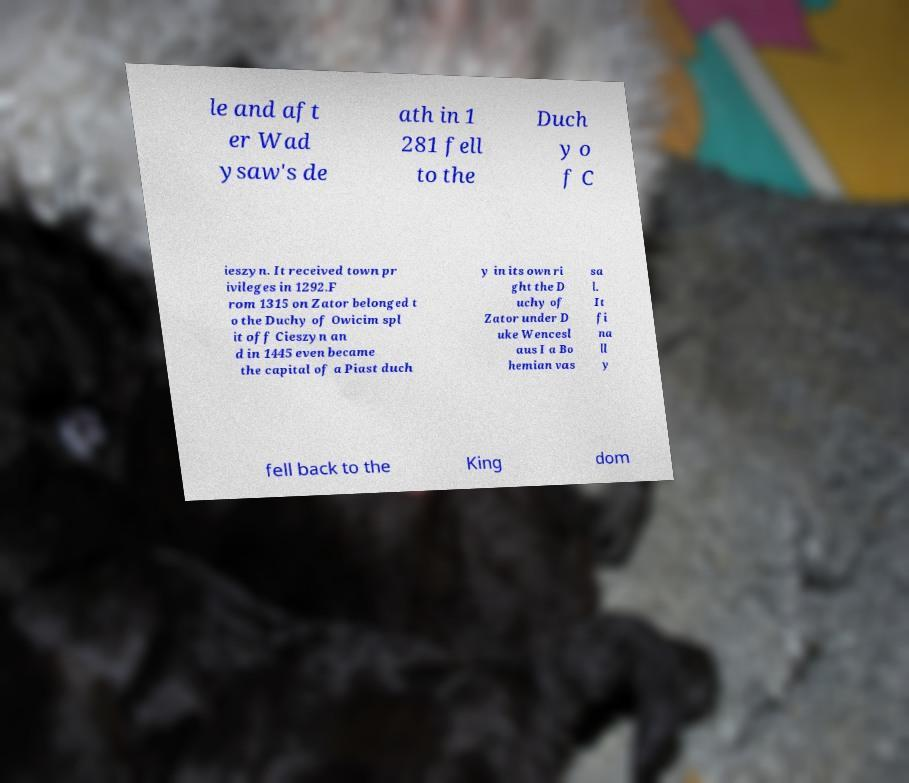Could you extract and type out the text from this image? le and aft er Wad ysaw's de ath in 1 281 fell to the Duch y o f C ieszyn. It received town pr ivileges in 1292.F rom 1315 on Zator belonged t o the Duchy of Owicim spl it off Cieszyn an d in 1445 even became the capital of a Piast duch y in its own ri ght the D uchy of Zator under D uke Wencesl aus I a Bo hemian vas sa l. It fi na ll y fell back to the King dom 